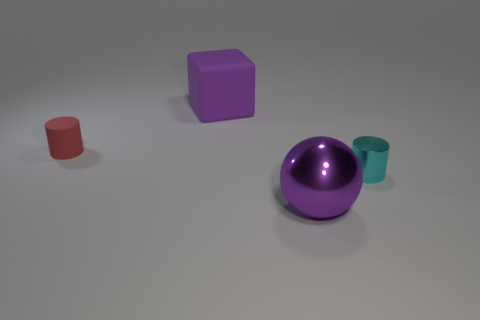Add 2 purple matte blocks. How many objects exist? 6 Subtract all balls. How many objects are left? 3 Subtract all green cylinders. Subtract all green cubes. How many cylinders are left? 2 Subtract all brown balls. How many green cylinders are left? 0 Subtract all balls. Subtract all gray metallic things. How many objects are left? 3 Add 2 blocks. How many blocks are left? 3 Add 2 cyan metallic things. How many cyan metallic things exist? 3 Subtract all cyan cylinders. How many cylinders are left? 1 Subtract 1 purple cubes. How many objects are left? 3 